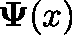<formula> <loc_0><loc_0><loc_500><loc_500>\Psi ( x )</formula> 